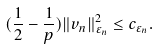Convert formula to latex. <formula><loc_0><loc_0><loc_500><loc_500>( \frac { 1 } { 2 } - \frac { 1 } { p } ) \| v _ { n } \| ^ { 2 } _ { \varepsilon _ { n } } \leq c _ { \varepsilon _ { n } } .</formula> 